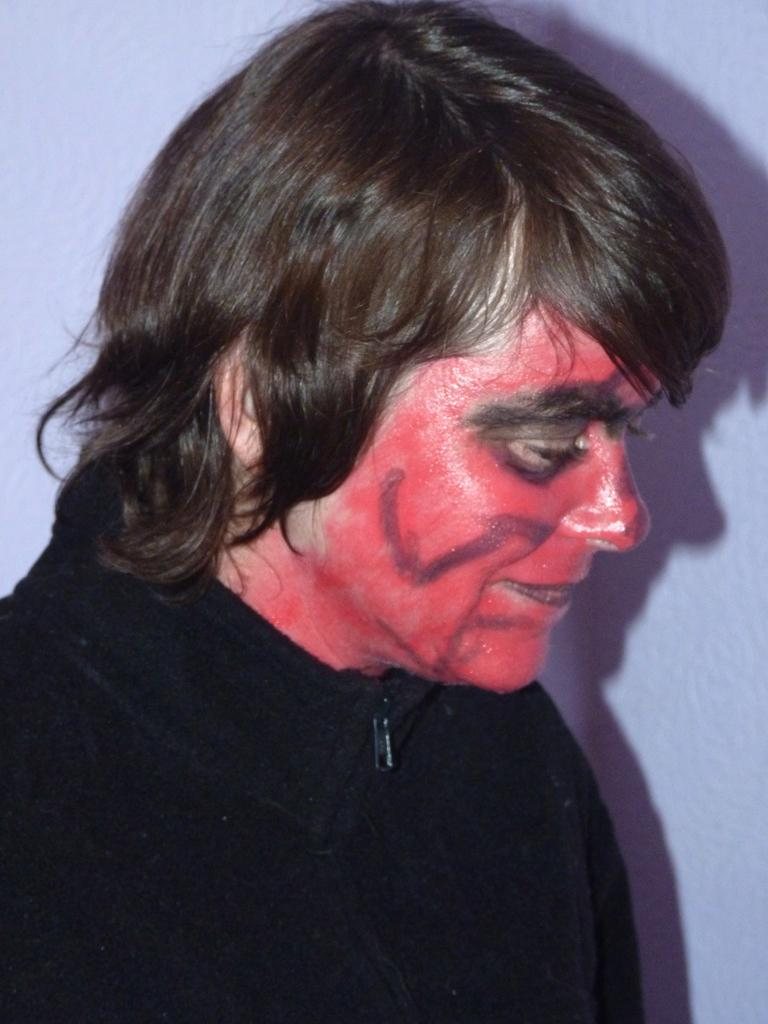Who is in the image? There is a person in the image. What is the person doing in the image? The person is smiling in the image. What can be seen on the person's face? The person has red color paint on their face. What is in the background of the image? There is a wall in the image. What else can be observed on the wall? The shadow of the person is visible on the wall. What type of wax is being used to create the person's shadow on the wall? There is no wax present in the image, and the person's shadow is a result of the light source and not a separate material. 